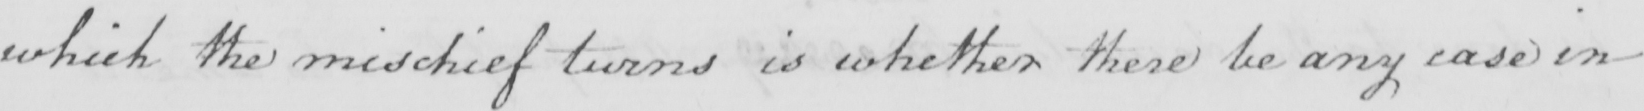Transcribe the text shown in this historical manuscript line. which the mischief turns is whether there be any case in 